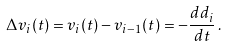<formula> <loc_0><loc_0><loc_500><loc_500>\Delta v _ { i } ( t ) = v _ { i } ( t ) - v _ { i - 1 } ( t ) = - \frac { d d _ { i } } { d t } \, .</formula> 